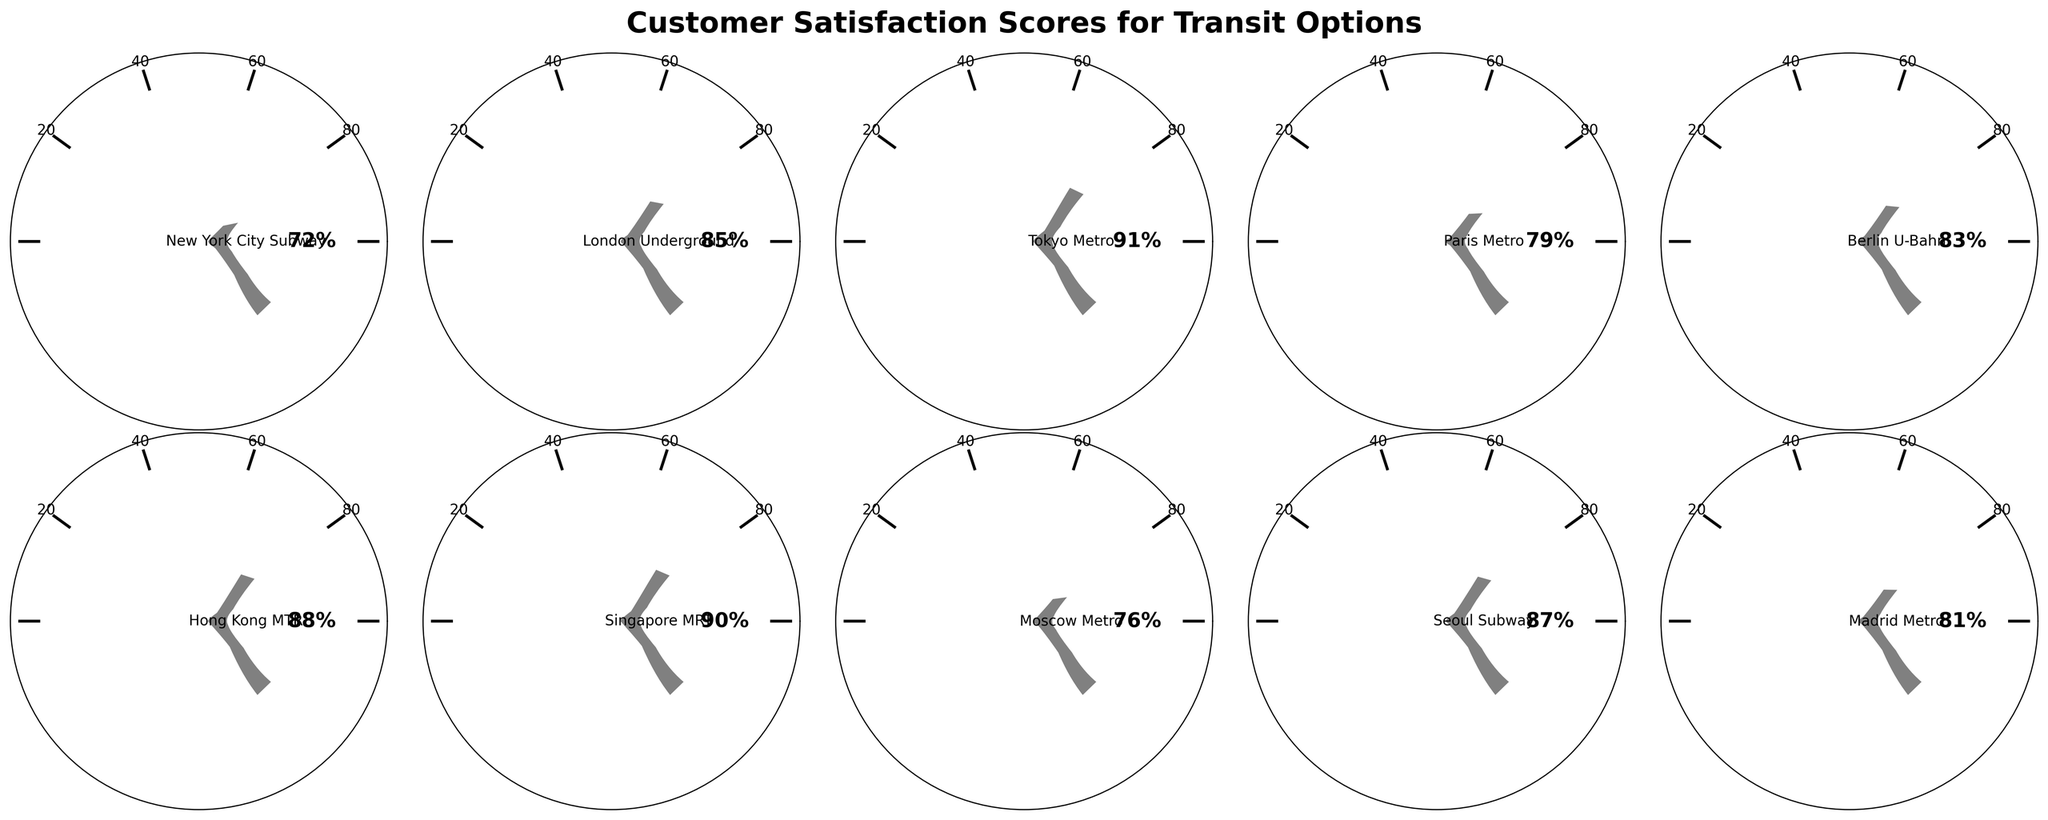What's the title of the figure? The title is usually prominently displayed at the top of the figure, providing an overview of what the chart represents. For this figure, it states the main subject.
Answer: Customer Satisfaction Scores for Transit Options Which transit option has the highest customer satisfaction score? By looking at all the gauges, we compare the percentage values displayed. The transit option with the highest score stands out.
Answer: Tokyo Metro Which transit option has the lowest customer satisfaction score? By scanning all the gauges, we find the one with the lowest percentage value. This transit option will have the smallest angle filled.
Answer: New York City Subway How many transit options have a satisfaction score above 80%? We count the gauges that have satisfaction scores greater than 80%. There are clear breaks shown to help identify these values.
Answer: 7 What is the average customer satisfaction score across all transit options? Sum all the satisfaction scores and divide by the total number of transit options. There are ten options: (72 + 85 + 91 + 79 + 83 + 88 + 90 + 76 + 87 + 81)/10.
Answer: 83.2 Which two transit options have satisfaction scores closest to each other? Compare the scores to find the smallest difference between any two scores. We see that Berlin U-Bahn (83) and London Underground (85) are closest.
Answer: Berlin U-Bahn and London Underground Is the satisfaction score of Tokyo Metro higher or lower than Singapore MRT? Tokyo Metro has a satisfaction score of 91%, and Singapore MRT has a score of 90%. Comparing these values determines which is higher.
Answer: Higher What percentage of the transit options have a satisfaction score less than 80%? Count the number of options with scores below 80%, then divide by the total number of transit options, and multiply by 100 to get the percentage. Three options (New York City Subway, Paris Metro, and Moscow Metro) have scores less than 80%. So, the calculation is (3/10) * 100.
Answer: 30% By how much does the satisfaction score of Hong Kong MTR exceed that of Moscow Metro? Subtract the satisfaction score of Moscow Metro from the satisfaction score of Hong Kong MTR: 88 - 76.
Answer: 12% What is the median customer satisfaction score of the transit options? To find the median, list all the scores in numerical order and find the middle value. If the number of scores is even, the median is the average of the two middle numbers. Scores sorted are: 72, 76, 79, 81, 83, 85, 87, 88, 90, 91. With ten scores, the median is the average of the 5th and 6th values: (83 + 85) / 2.
Answer: 84 